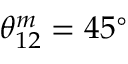Convert formula to latex. <formula><loc_0><loc_0><loc_500><loc_500>\theta _ { 1 2 } ^ { m } = 4 5 ^ { \circ }</formula> 